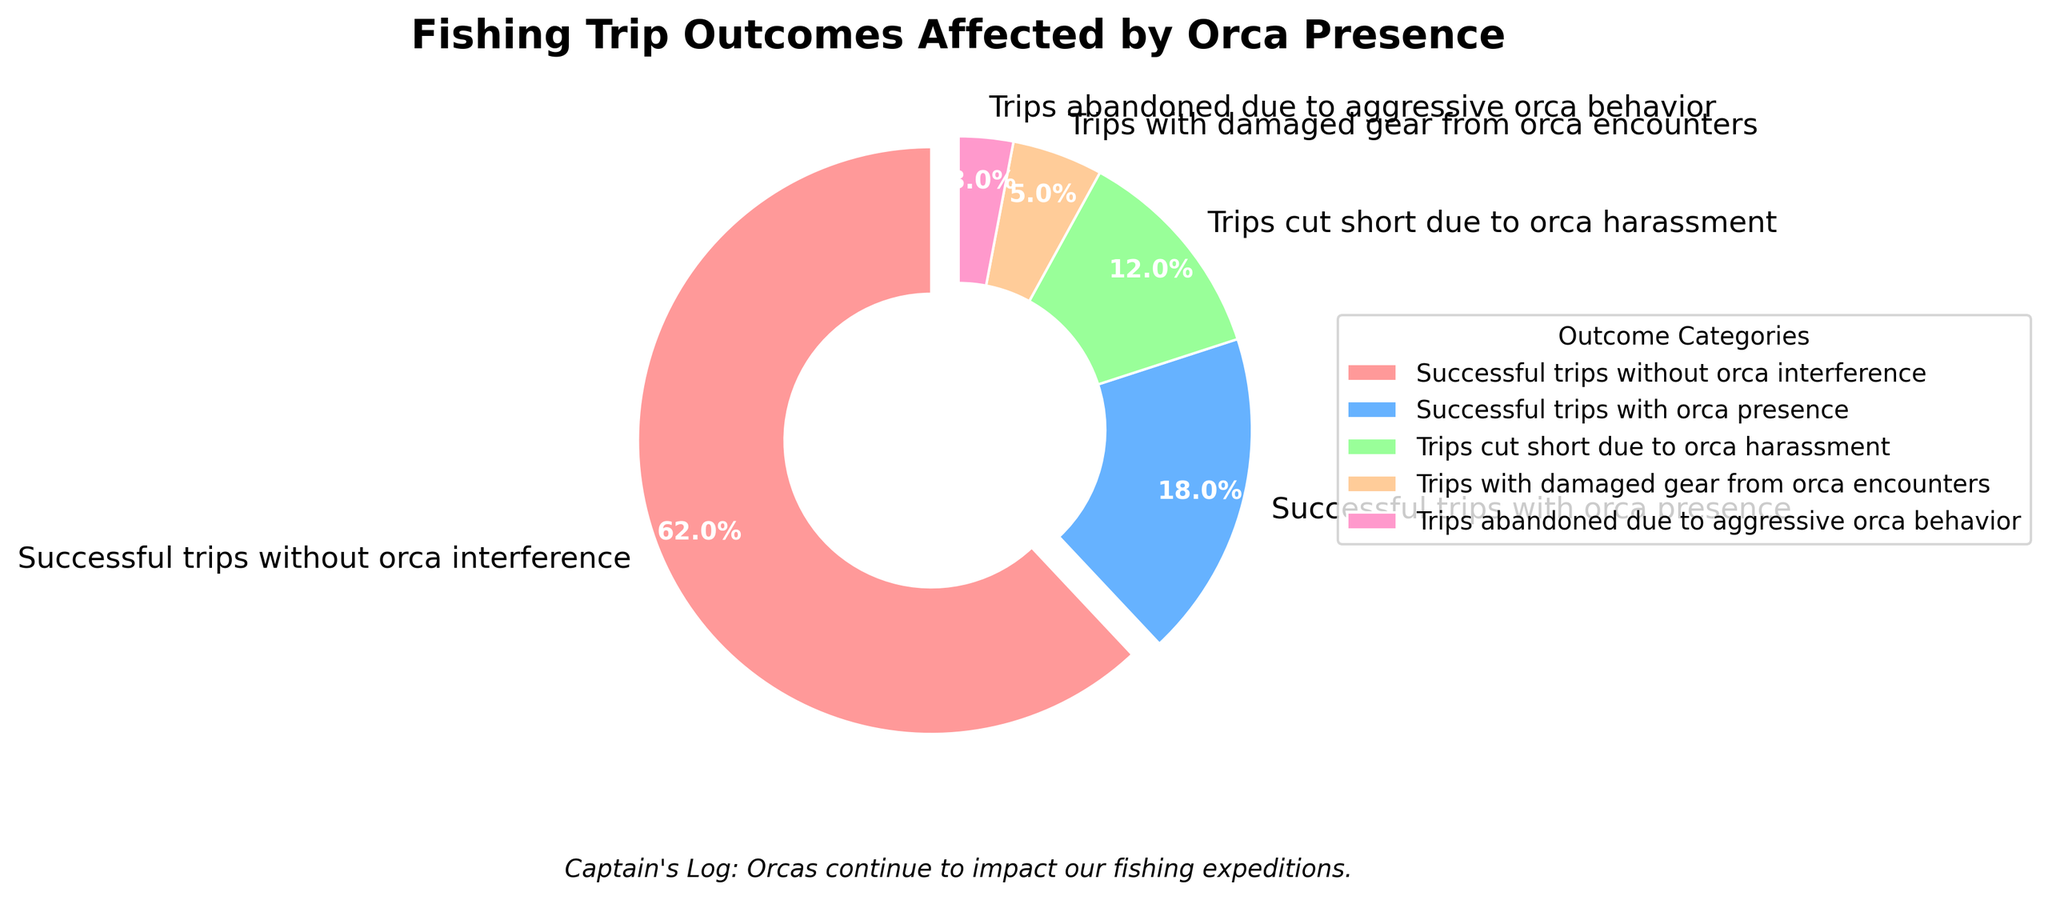What's the most common outcome of fishing trips in the presence of orcas? The most common outcome can be identified by looking at the largest segment of the pie chart. The "Successful trips without orca interference" segment is the largest.
Answer: Successful trips without orca interference How many percentage points greater are successful trips without orca interference compared to successful trips with orca presence? Subtract the percentage points of "Successful trips with orca presence" from "Successful trips without orca interference" (62 - 18).
Answer: 44 percentage points What is the total percentage of trips affected by orca presence in some disruptive way (not including successful trips with orca presence)? Add the percentages of "Trips cut short due to orca harassment," "Trips with damaged gear from orca encounters," and "Trips abandoned due to aggressive orca behavior." (12 + 5 + 3).
Answer: 20% Which category of trips affected by orcas is the smallest? The smallest segment on the pie chart corresponds to the "Trips abandoned due to aggressive orca behavior" category.
Answer: Trips abandoned due to aggressive orca behavior What is the combined percentage for all kinds of trips affected by orca presence (including successful trips with orca presence)? Add the percentages for "Successful trips with orca presence," "Trips cut short due to orca harassment," "Trips with damaged gear from orca encounters," and "Trips abandoned due to aggressive orca behavior." (18 + 12 + 5 + 3).
Answer: 38% Which is greater: the percentage of successful trips without orca interference or the sum of all trips affected by orca presence? Compare the percentage of "Successful trips without orca interference" (62%) with the combined percentage of all trips affected by orca presence (38%). Since 62% is greater than 38%, "Successful trips without orca interference" is greater.
Answer: Successful trips without orca interference By how much does the percentage of "Trips cut short due to orca harassment" exceed the percentage of "Trips with damaged gear from orca encounters"? Subtract the percentage of "Trips with damaged gear from orca encounters" from "Trips cut short due to orca harassment" (12 - 5).
Answer: 7 percentage points What color represents the "Trips with damaged gear from orca encounters" category in the pie chart? Identify the color associated with the label "Trips with damaged gear from orca encounters" in the legend or directly from the pie chart. The color is an orangish shade.
Answer: Orangish shade Which visual attribute differentiates the "Successful trips without orca interference" segment from the other segments in the pie chart? The "Successful trips without orca interference" segment is visually distinct because it is slightly exploded out from the center of the pie chart.
Answer: Exploded out from the center What portion of the pie chart represents the least frequent outcome? Look for the smallest segment in the pie chart, which corresponds to the "Trips abandoned due to aggressive orca behavior" at 3%.
Answer: 3% 